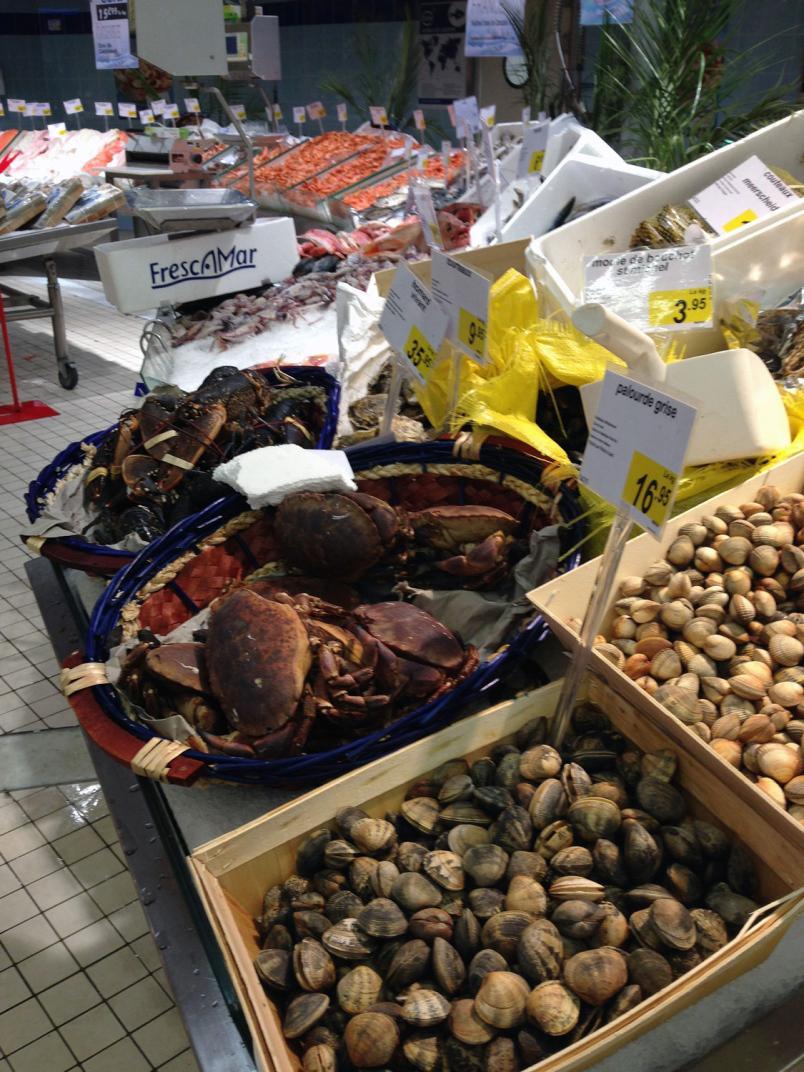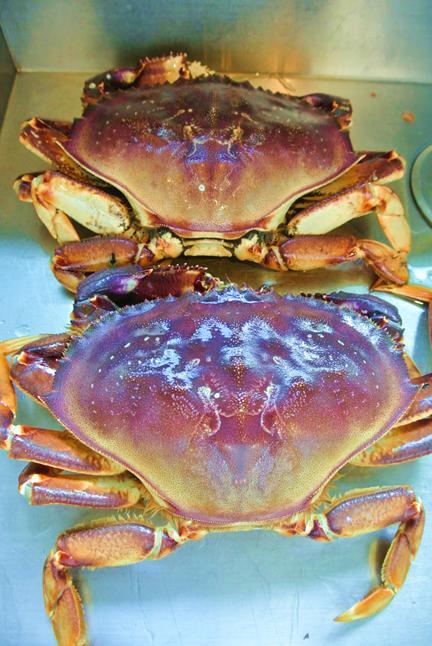The first image is the image on the left, the second image is the image on the right. Assess this claim about the two images: "The crabs in both of the images sit in dishes.". Correct or not? Answer yes or no. No. 